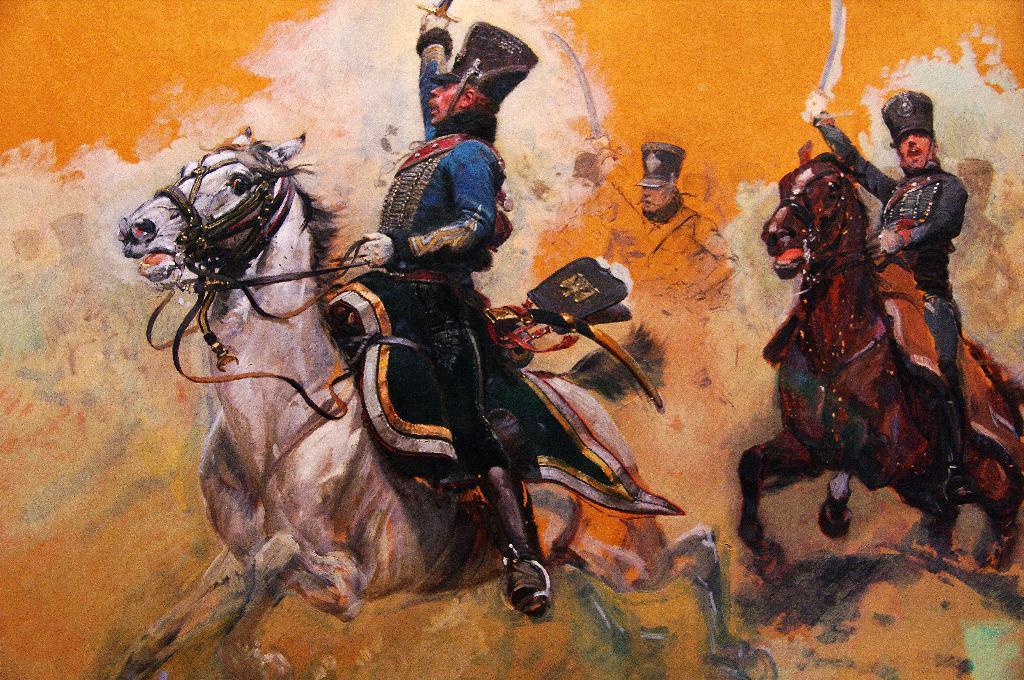Can you describe this image briefly? In this painted picture I can see people are sitting on horses and holding weapons. 